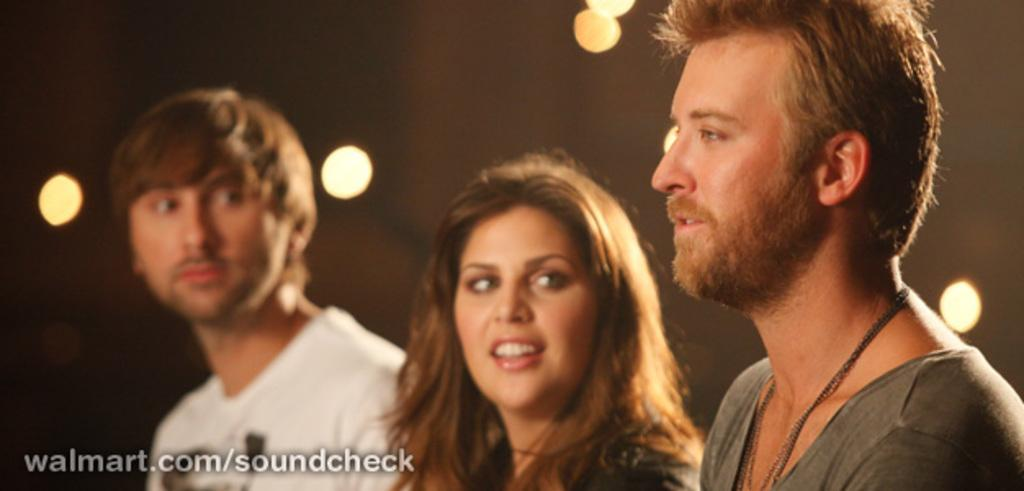How many people are present in the image? There are three people in the image. Can you describe the subjects in the image? There is a man, a woman, and another man in the image. What are the first two subjects doing? The man and woman are staring at the third man. Where is the third man located in relation to the first two subjects? The third man is standing on the left side of the first two subjects. What type of crook is the third man holding in the image? There is no crook present in the image. Can you tell me how many rifles are visible in the image? There are no rifles visible in the image. 